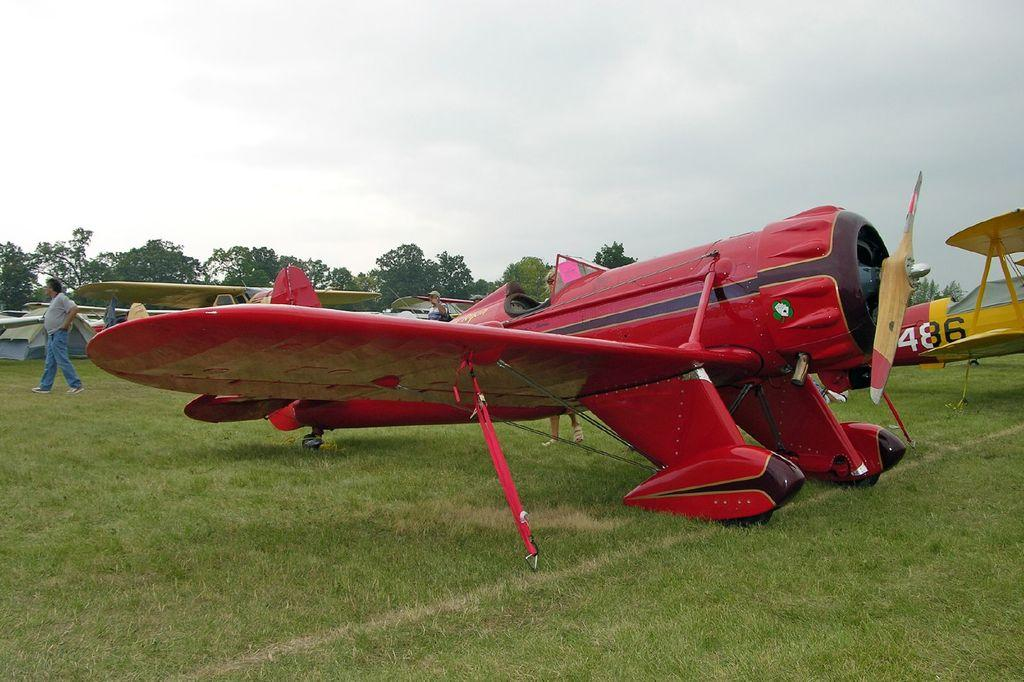Provide a one-sentence caption for the provided image. A yellow plane numbered 486 is behind a red plane. 